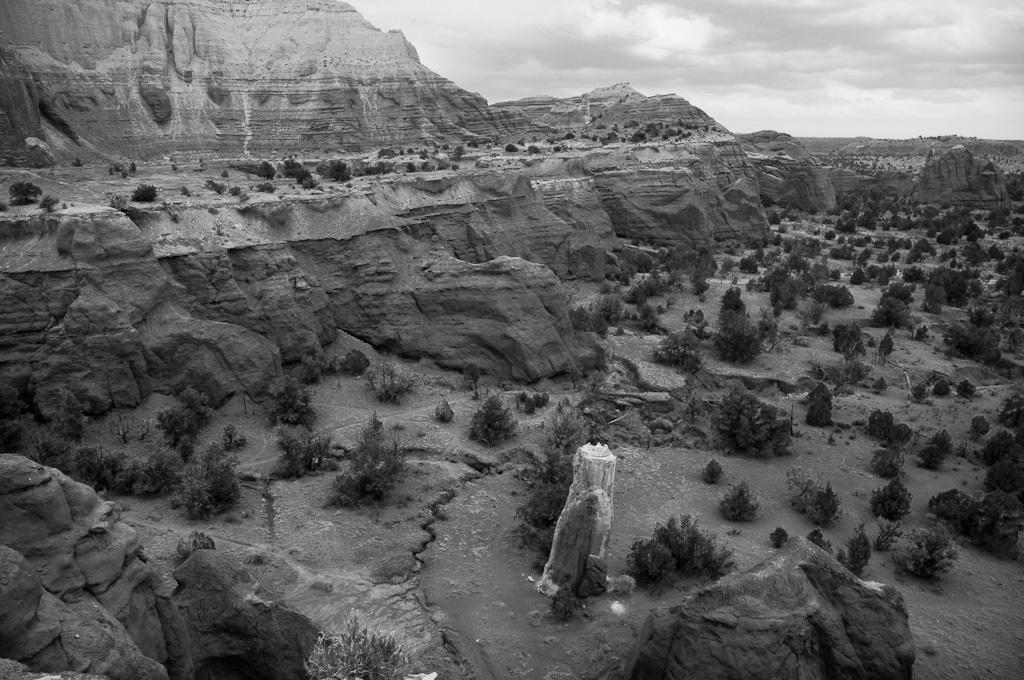What is the color scheme of the image? The image is black and white. What type of landscape is depicted in the image? The image appears to depict plateaus. What type of vegetation can be seen in the image? There are trees and bushes in the image. What is visible in the background of the image? The sky is visible in the image. What type of board game is being played on the plateau in the image? There is no board game present in the image; it depicts a natural landscape with plateaus, trees, and bushes. What type of wine is being served in the image? There is no wine or any indication of food or drink in the image. 